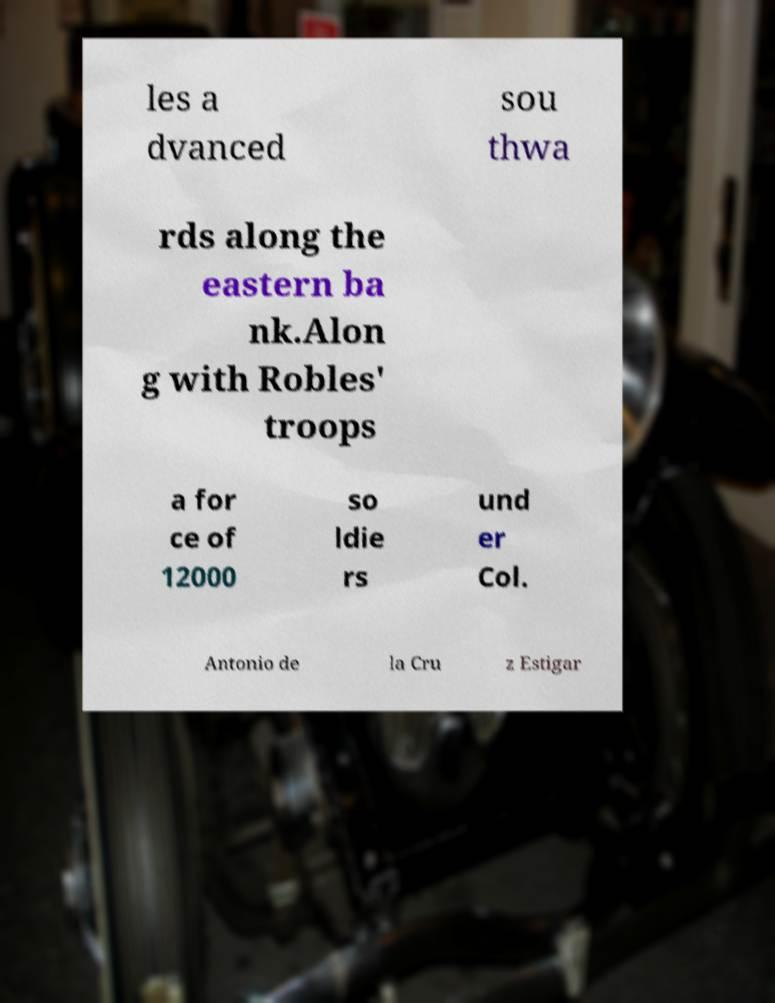Please read and relay the text visible in this image. What does it say? les a dvanced sou thwa rds along the eastern ba nk.Alon g with Robles' troops a for ce of 12000 so ldie rs und er Col. Antonio de la Cru z Estigar 